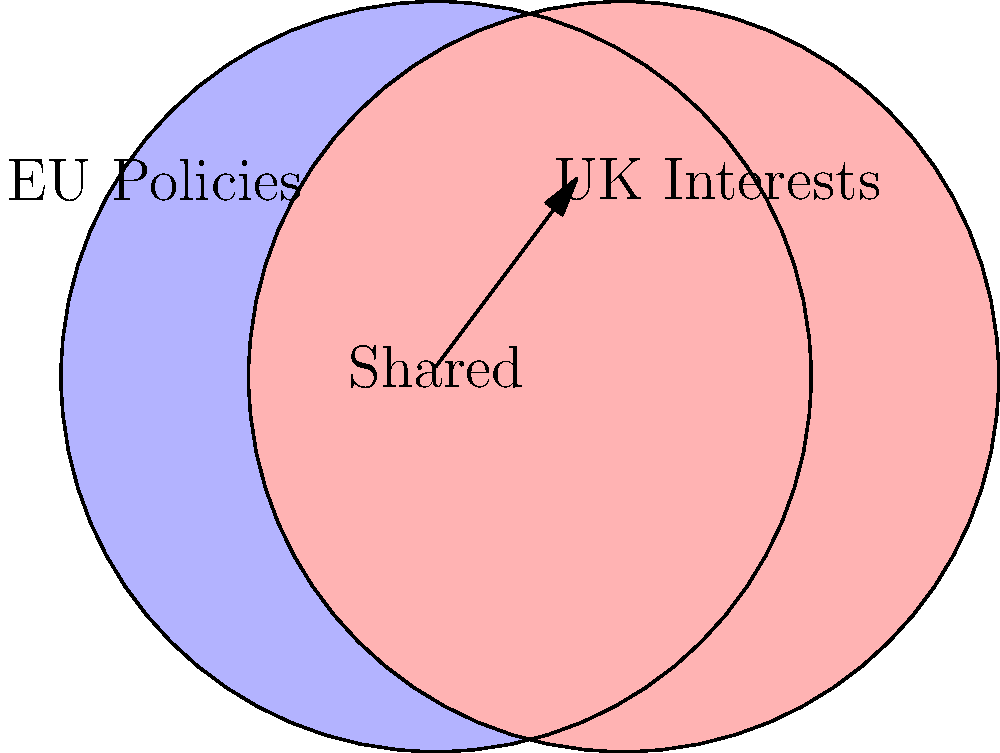Based on the Venn diagram, which area represents policies and interests that were likely the most challenging to negotiate during the Brexit transition period, and why? To answer this question, we need to analyze the Venn diagram:

1. The blue circle represents EU Policies.
2. The red circle represents UK Interests.
3. The overlapping area (purple) represents Shared policies and interests.

The most challenging area to negotiate would likely be the overlapping section because:

1. It represents policies and interests that are important to both the EU and the UK.
2. These shared areas require careful consideration to ensure both parties' needs are met.
3. Negotiations would need to balance maintaining EU integrity while accommodating UK sovereignty.
4. Any changes in this area could have significant impacts on both the EU and the UK.
5. The transition period aimed to smooth out these shared interests, making them crucial for negotiation.

The non-overlapping areas, while important, would be less challenging as they represent distinct interests of each party and may not require as much compromise.
Answer: The overlapping (shared) area, as it represents policies important to both parties requiring careful negotiation and compromise. 